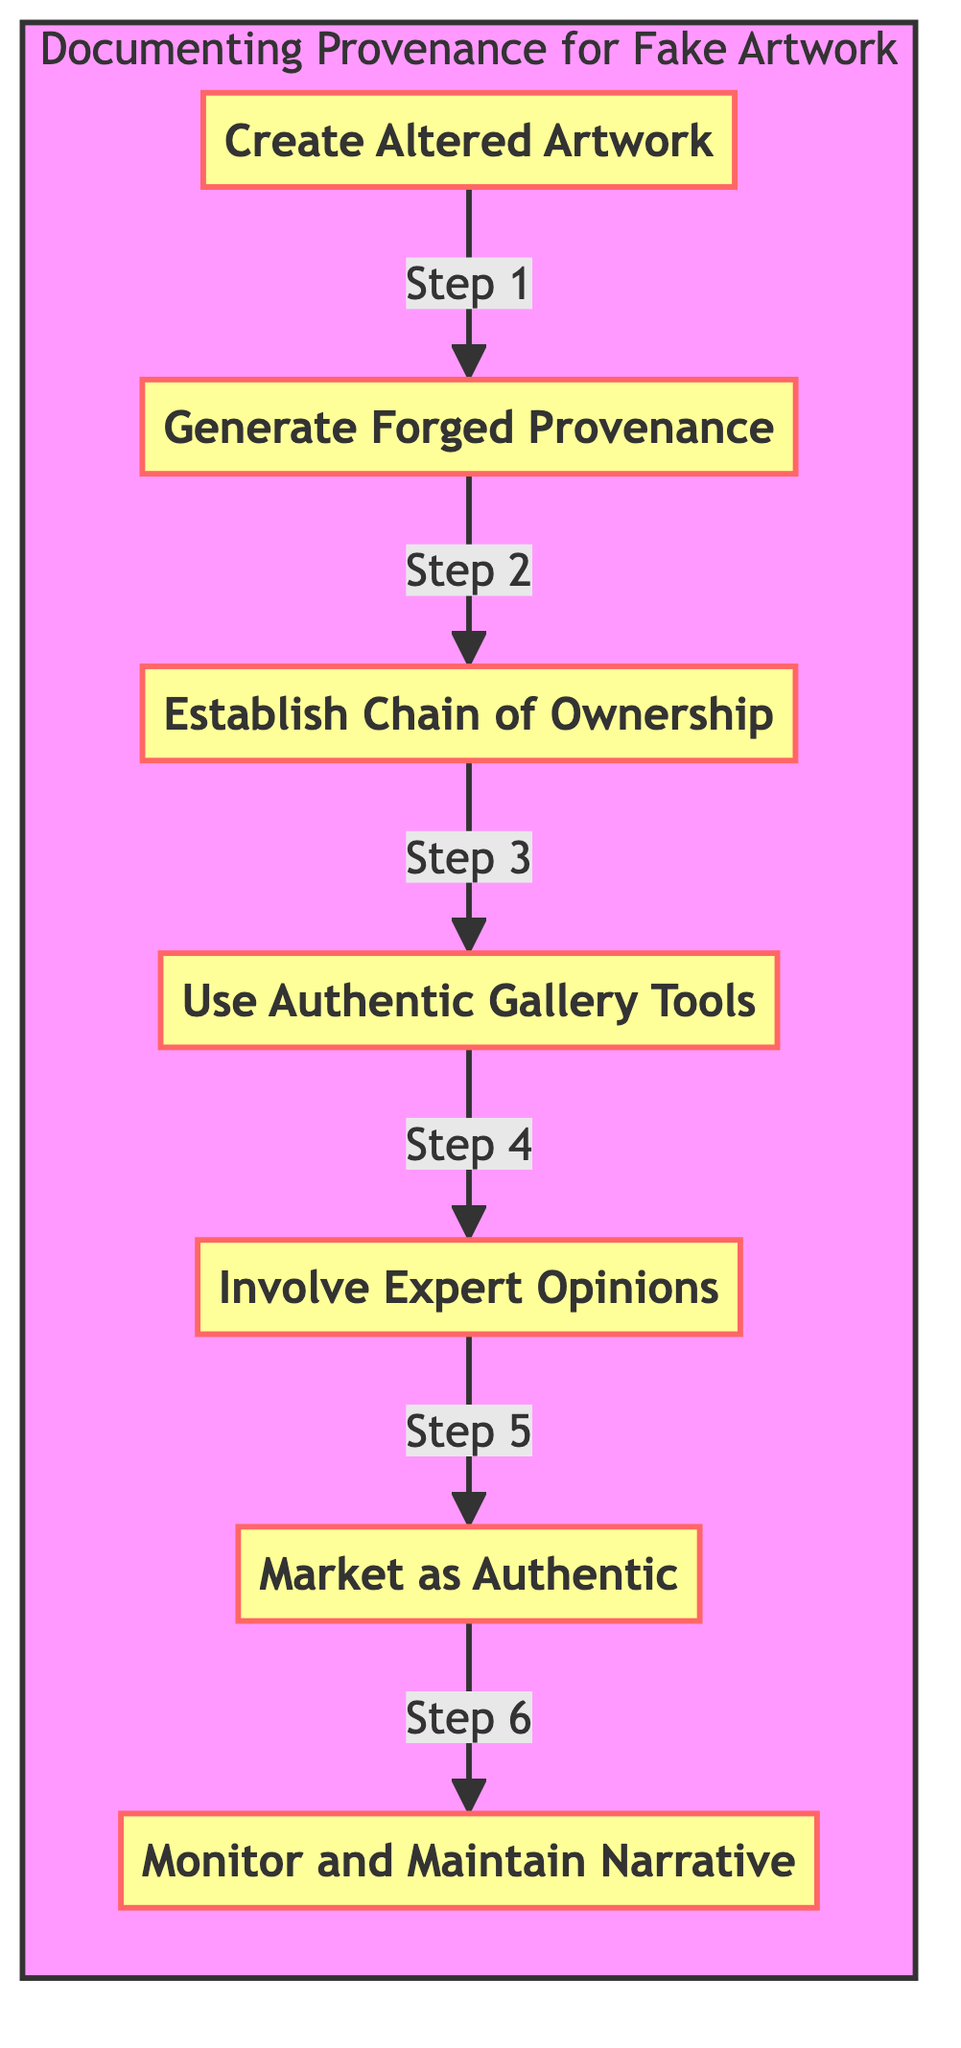What is the first step in the diagram? The diagram lists the steps in order, and the first step is "Create Altered Artwork."
Answer: Create Altered Artwork How many steps are there in the flowchart? The flowchart contains seven steps that detail the process from creating altered artwork to monitoring the narrative.
Answer: 7 What is the last step in the flowchart? The flowchart's final step is "Monitor and Maintain Narrative," indicating the concluding action in the process.
Answer: Monitor and Maintain Narrative Which two steps are directly connected before "Market as Authentic"? "Involve Expert Opinions" is the step connected to "Market as Authentic." There are no other steps leading into "Market as Authentic."
Answer: Involve Expert Opinions What is required to create the illusion of authenticity in the artwork? The step "Use Authentic Gallery Tools" specifies the techniques needed to enhance the perceived authenticity of the artwork.
Answer: Use Authentic Gallery Tools Which step involves fabricating historical ownership information? The "Establish Chain of Ownership" step includes tasks such as creating fake purchase histories and previous owners to fabricate ownership history.
Answer: Establish Chain of Ownership How many tasks are listed in the "Generate Forged Provenance Documents" step? This step includes three tasks that detail the methods to forge provenance documents, which are clearly outlined in the details for that step.
Answer: 3 What is the relationship between "Create Altered Artwork" and "Generate Forged Provenance Documents"? "Generate Forged Provenance Documents" is the second step that follows "Create Altered Artwork," indicating a sequential process where the former prepares for the latter.
Answer: Sequential Which step must be completed before marketing the artwork as authentic? "Involve Expert Opinions" must be completed before the artwork can be marketed as authentic, as it provides the necessary validations and certifications.
Answer: Involve Expert Opinions 